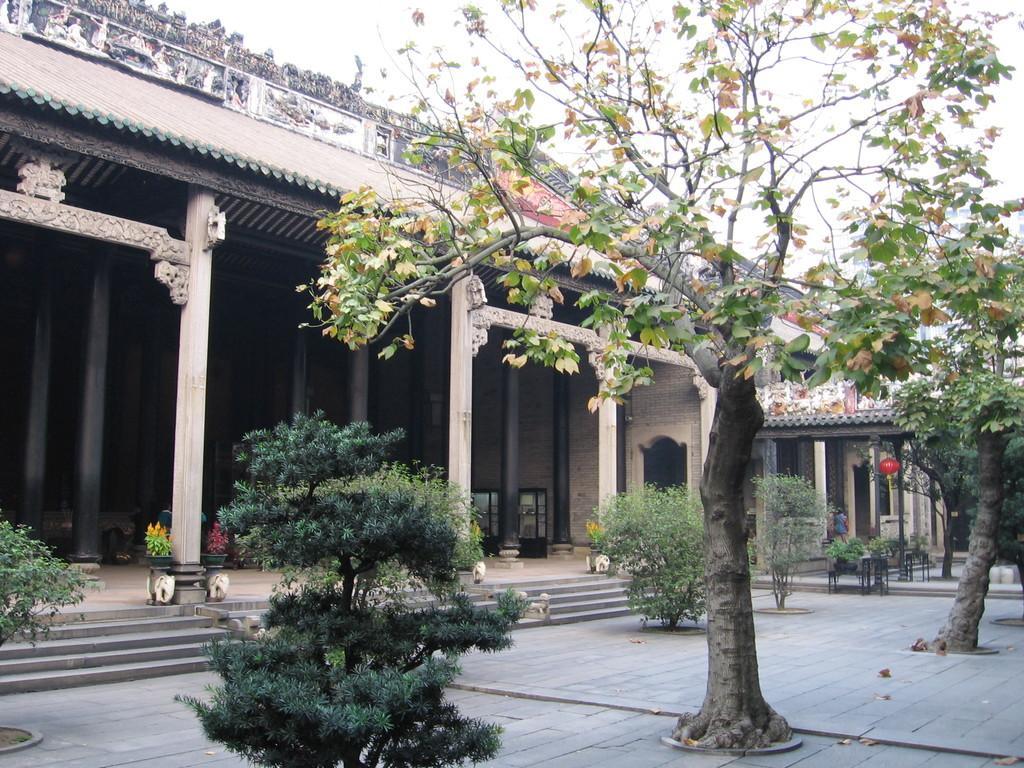Could you give a brief overview of what you see in this image? In this image I can see plants and trees in the front. There are stairs, pillars and a building at the back. There is a red ball lantern hanging at the back. A person is present at the back. There is sky at the top. 